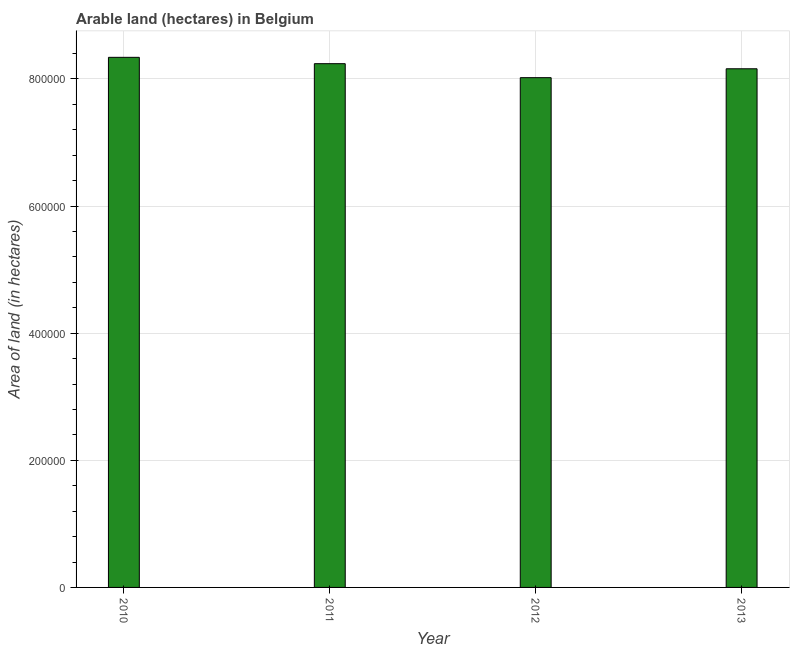What is the title of the graph?
Provide a succinct answer. Arable land (hectares) in Belgium. What is the label or title of the X-axis?
Provide a succinct answer. Year. What is the label or title of the Y-axis?
Provide a short and direct response. Area of land (in hectares). What is the area of land in 2013?
Provide a succinct answer. 8.16e+05. Across all years, what is the maximum area of land?
Offer a terse response. 8.34e+05. Across all years, what is the minimum area of land?
Offer a very short reply. 8.02e+05. What is the sum of the area of land?
Keep it short and to the point. 3.28e+06. What is the difference between the area of land in 2010 and 2012?
Give a very brief answer. 3.20e+04. What is the average area of land per year?
Provide a succinct answer. 8.19e+05. What is the median area of land?
Your answer should be very brief. 8.20e+05. In how many years, is the area of land greater than 280000 hectares?
Offer a very short reply. 4. Is the area of land in 2010 less than that in 2013?
Ensure brevity in your answer.  No. Is the sum of the area of land in 2010 and 2013 greater than the maximum area of land across all years?
Provide a short and direct response. Yes. What is the difference between the highest and the lowest area of land?
Make the answer very short. 3.20e+04. In how many years, is the area of land greater than the average area of land taken over all years?
Keep it short and to the point. 2. How many bars are there?
Keep it short and to the point. 4. What is the Area of land (in hectares) of 2010?
Your answer should be compact. 8.34e+05. What is the Area of land (in hectares) in 2011?
Your response must be concise. 8.24e+05. What is the Area of land (in hectares) in 2012?
Your answer should be very brief. 8.02e+05. What is the Area of land (in hectares) in 2013?
Ensure brevity in your answer.  8.16e+05. What is the difference between the Area of land (in hectares) in 2010 and 2012?
Provide a short and direct response. 3.20e+04. What is the difference between the Area of land (in hectares) in 2010 and 2013?
Keep it short and to the point. 1.80e+04. What is the difference between the Area of land (in hectares) in 2011 and 2012?
Keep it short and to the point. 2.20e+04. What is the difference between the Area of land (in hectares) in 2011 and 2013?
Provide a short and direct response. 8000. What is the difference between the Area of land (in hectares) in 2012 and 2013?
Your response must be concise. -1.40e+04. What is the ratio of the Area of land (in hectares) in 2010 to that in 2011?
Keep it short and to the point. 1.01. What is the ratio of the Area of land (in hectares) in 2011 to that in 2012?
Your answer should be compact. 1.03. 